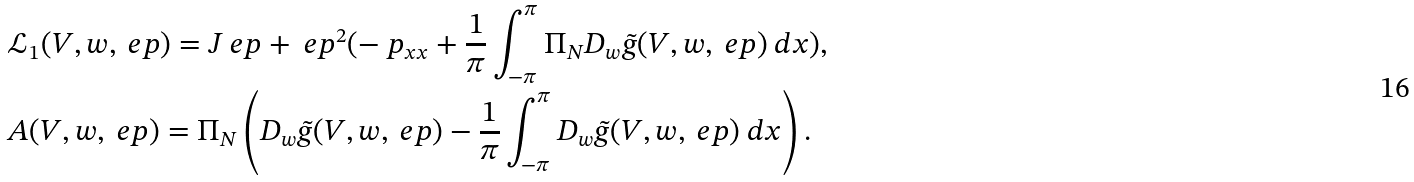<formula> <loc_0><loc_0><loc_500><loc_500>& \mathcal { L } _ { 1 } ( V , w , \ e p ) = J _ { \ } e p + \ e p ^ { 2 } ( - \ p _ { x x } + \frac { 1 } { \pi } \int _ { - \pi } ^ { \pi } \Pi _ { N } D _ { w } \tilde { g } ( V , w , \ e p ) \ d x ) , \\ & A ( V , w , \ e p ) = \Pi _ { N } \left ( D _ { w } \tilde { g } ( V , w , \ e p ) - \frac { 1 } { \pi } \int _ { - \pi } ^ { \pi } D _ { w } \tilde { g } ( V , w , \ e p ) \ d x \right ) .</formula> 